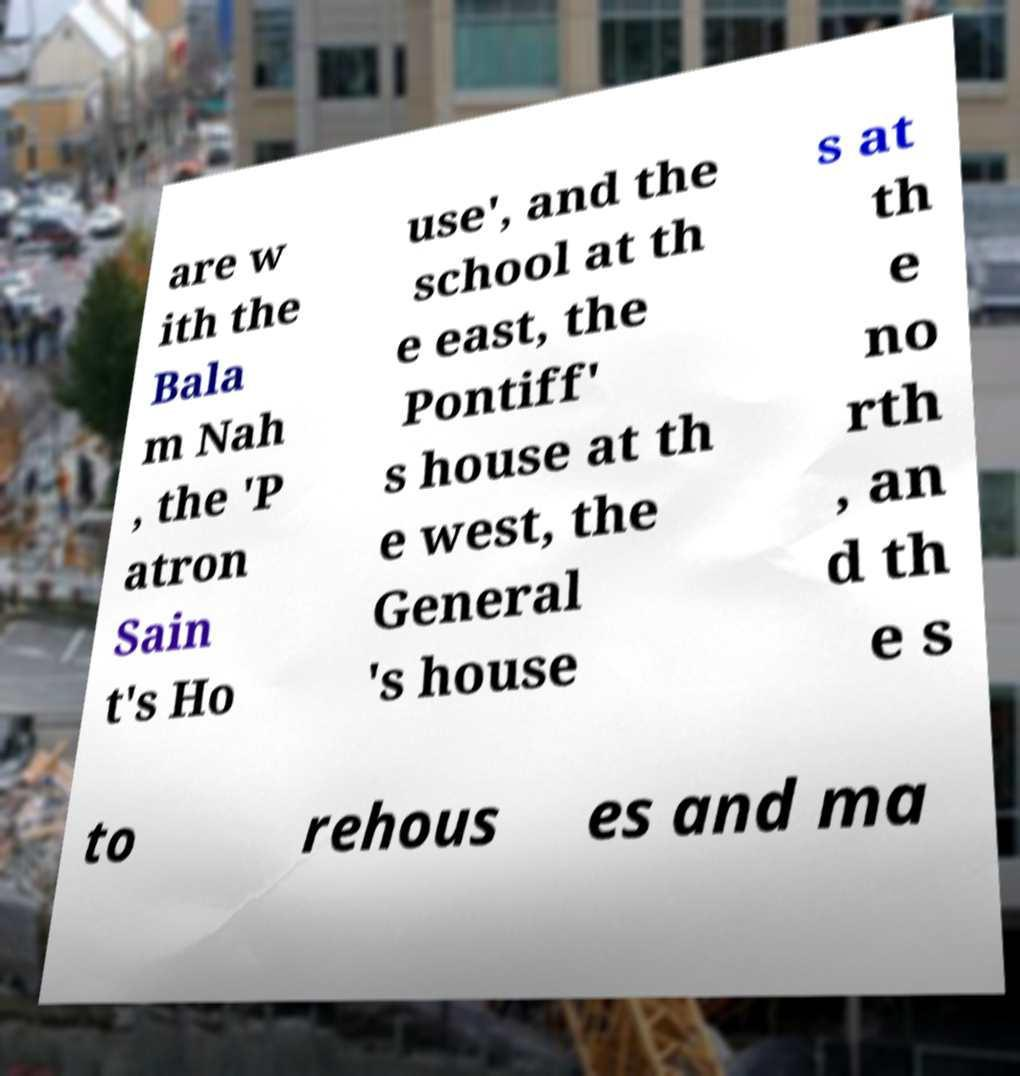Could you assist in decoding the text presented in this image and type it out clearly? are w ith the Bala m Nah , the 'P atron Sain t's Ho use', and the school at th e east, the Pontiff' s house at th e west, the General 's house s at th e no rth , an d th e s to rehous es and ma 